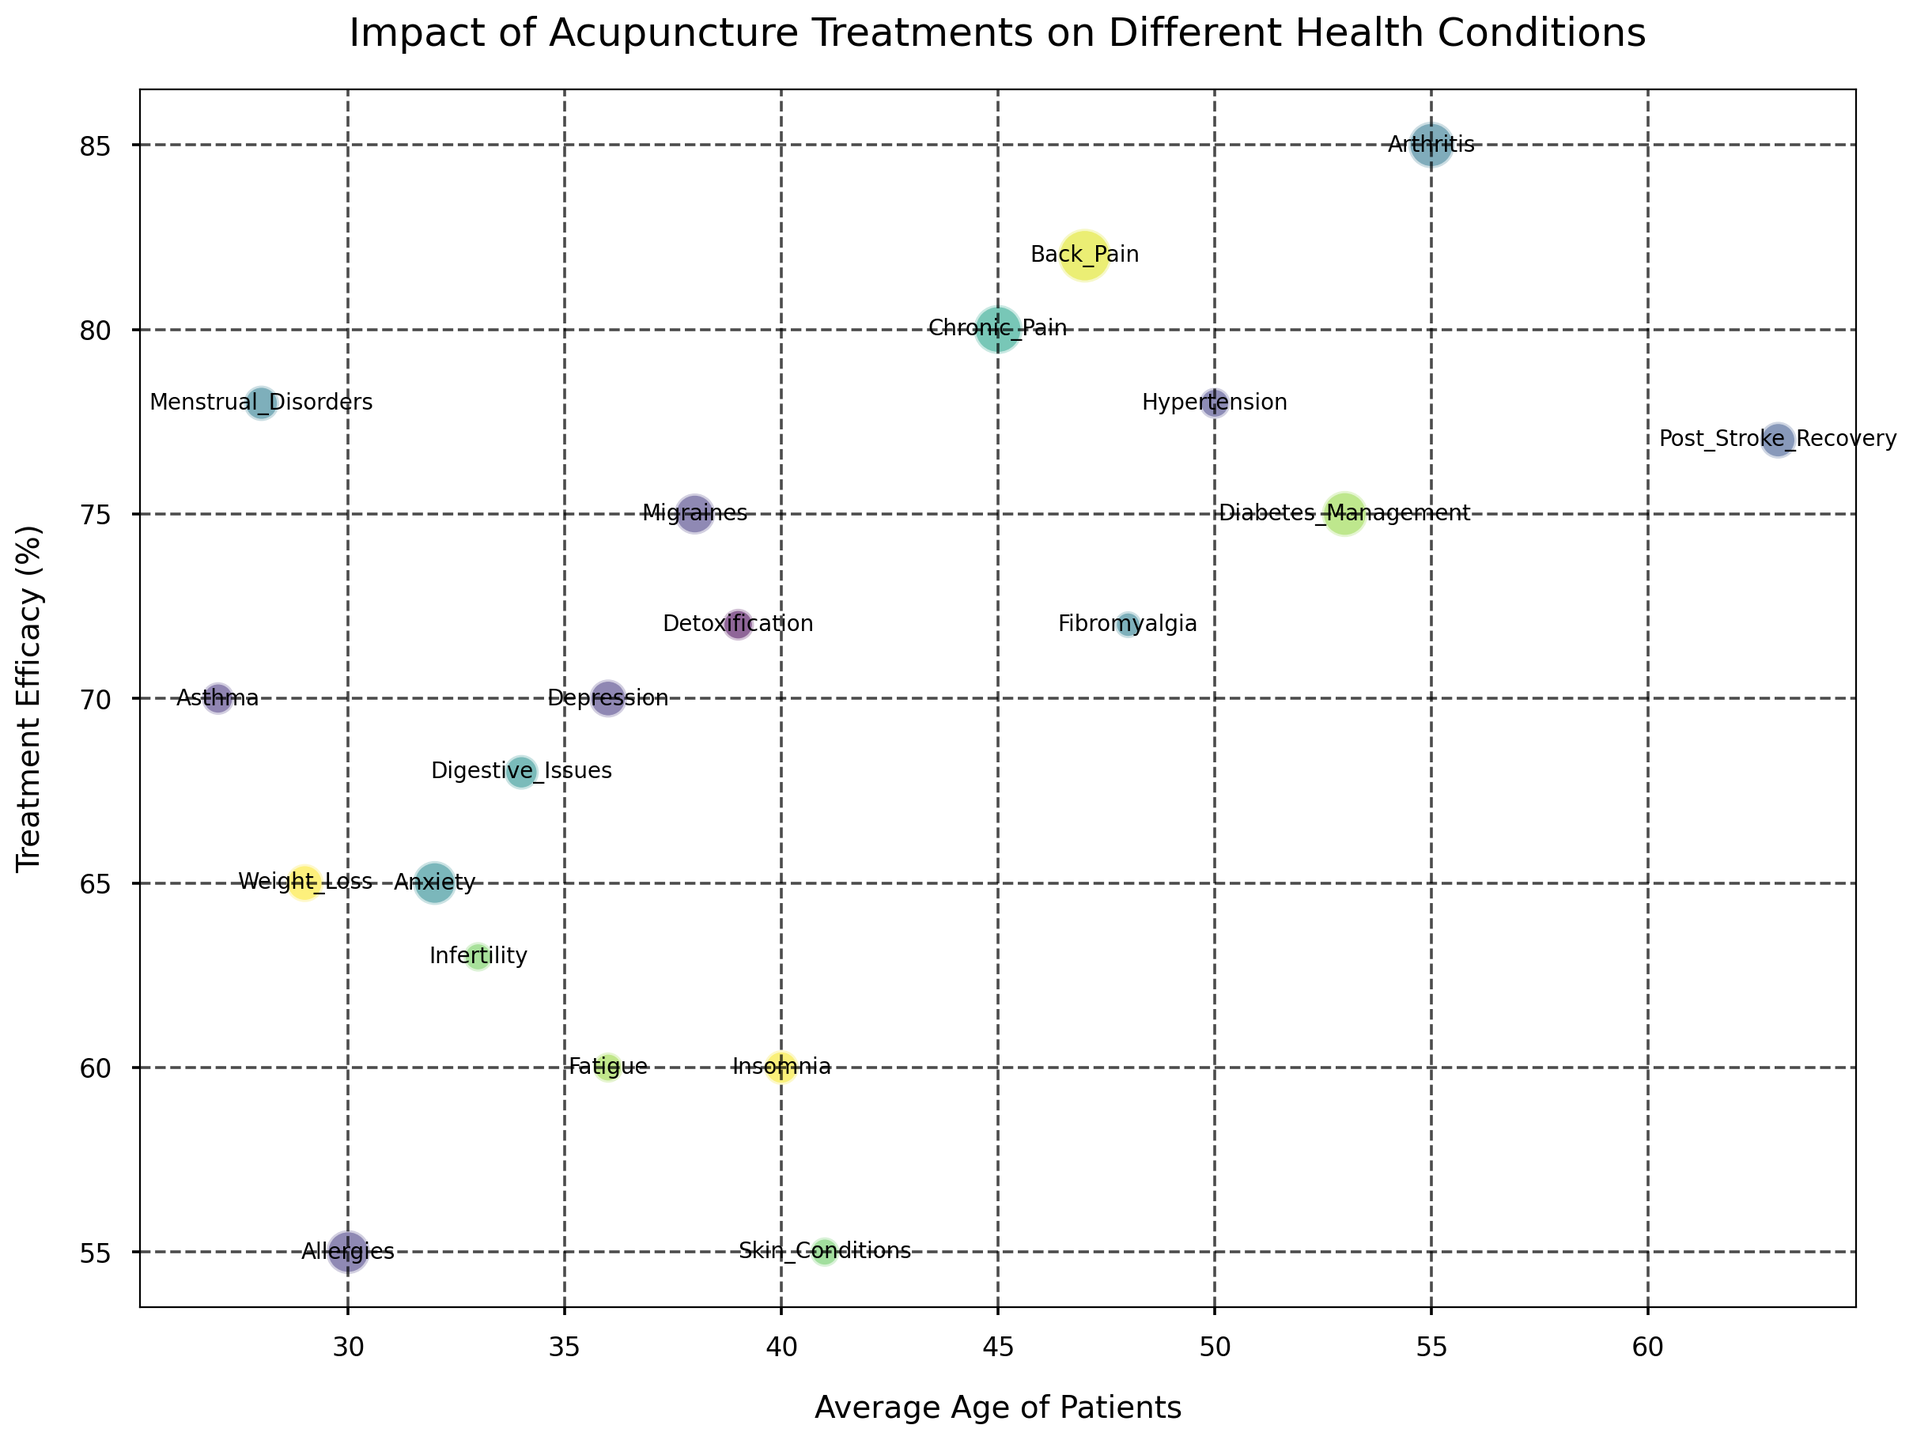Which health condition has the highest treatment efficacy? By observing the y-axis of the plot, the highest point reached by a bubble represents the condition with the highest treatment efficacy.
Answer: Arthritis Which health condition has the largest number of patients? The size of the bubbles indicates the number of patients. The largest bubble represents the health condition with the largest number of patients.
Answer: Back Pain Among the health conditions, which one has the lowest treatment efficacy and how old are the patients on average? Identify the smallest y-value to find the lowest treatment efficacy and then check the corresponding x-value to find the average age.
Answer: Allergies, 30 years old Which health condition is represented by the bubble closest to the bottom right corner of the chart? The bottom right corner represents high average age and low treatment efficacy. Locate the bubble closest to these axis limits visually.
Answer: Insomnia Compare the efficacy of treatment and number of patients for Chronic Pain and Back Pain. Which condition has higher efficacy and more patients? Check the y-value (treatment efficacy) and the size of the bubbles (number of patients) for Chronic Pain and Back Pain. Back Pain has higher efficacy at 82% vs. Chronic Pain at 80%, and Back Pain has more patients since its bubble is larger.
Answer: Back Pain Which health condition has a higher treatment efficacy: Post Stroke Recovery or Fibromyalgia? Compare the y-values of the bubbles labeled Post Stroke Recovery and Fibromyalgia to determine which is higher. Post Stroke Recovery has a higher y-value at 77% efficacy versus Fibromyalgia at 72%.
Answer: Post Stroke Recovery What is the average age of patients for the condition with the second highest treatment efficacy? Find the second-highest y-value, which corresponds to Back Pain, then check the x-value for the average age.
Answer: 47 years old Which condition among Menstrual Disorders, Diabetes Management, and Migraines has the highest treatment efficacy? Compare the y-values labeled Menstrual Disorders, Diabetes Management, and Migraines, and find the highest. Very closely refer to the plot.
Answer: Menstrual Disorders What is the difference in the average ages of patients with hypertension and those with arthritis? From the plot, find the x-values for Hypertension (50) and Arthritis (55), then compute 55 - 50.
Answer: 5 years Which health condition with patients averaging around 38 years offers a treatment efficacy of over 70%? Locate the bubble around the 38 mark on the x-axis that has a y-value over 70%.
Answer: Migraines 